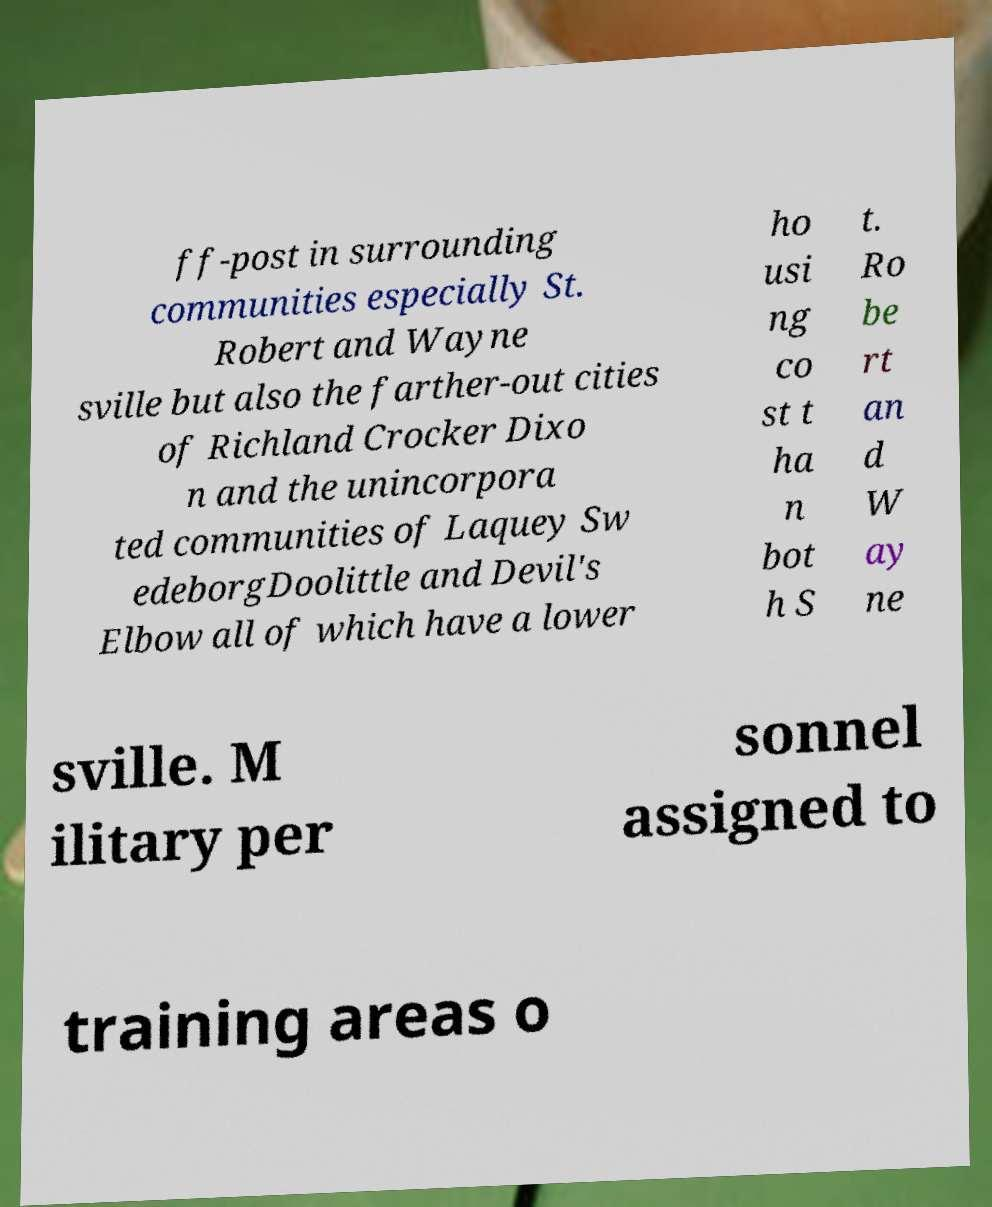Could you extract and type out the text from this image? ff-post in surrounding communities especially St. Robert and Wayne sville but also the farther-out cities of Richland Crocker Dixo n and the unincorpora ted communities of Laquey Sw edeborgDoolittle and Devil's Elbow all of which have a lower ho usi ng co st t ha n bot h S t. Ro be rt an d W ay ne sville. M ilitary per sonnel assigned to training areas o 